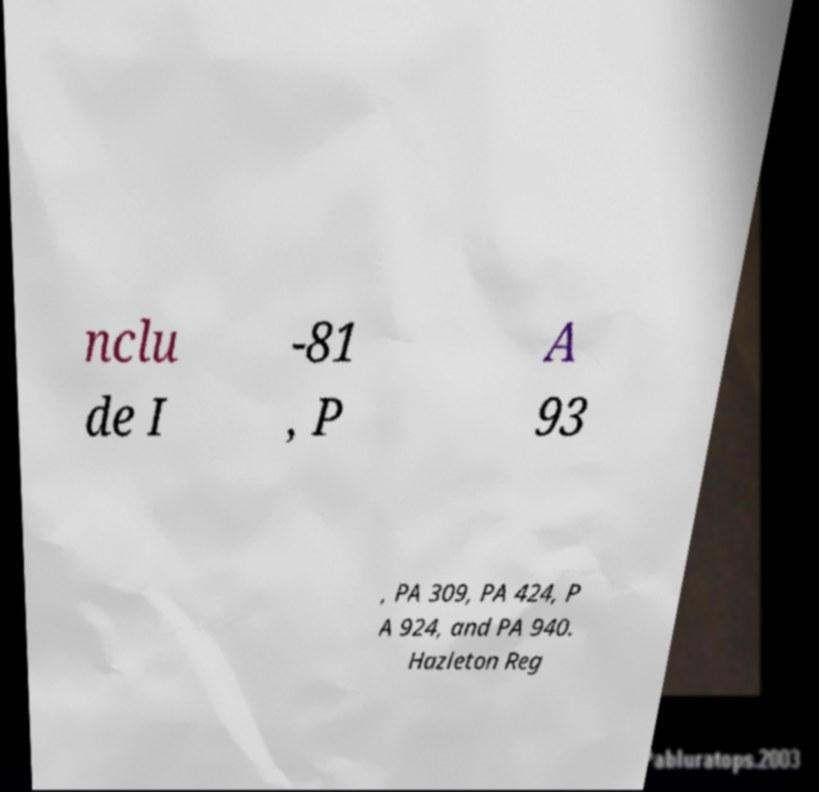What messages or text are displayed in this image? I need them in a readable, typed format. nclu de I -81 , P A 93 , PA 309, PA 424, P A 924, and PA 940. Hazleton Reg 